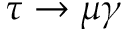<formula> <loc_0><loc_0><loc_500><loc_500>\tau \to \mu \gamma</formula> 